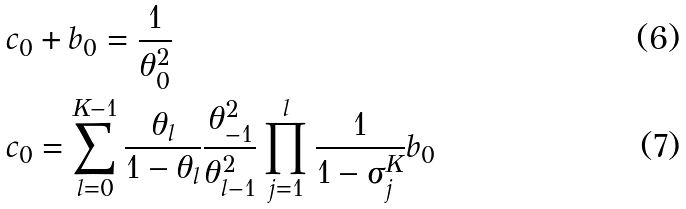<formula> <loc_0><loc_0><loc_500><loc_500>c _ { 0 } & + b _ { 0 } = \frac { 1 } { \theta _ { 0 } ^ { 2 } } \\ c _ { 0 } & = \sum _ { l = 0 } ^ { K - 1 } \frac { \theta _ { l } } { 1 - \theta _ { l } } \frac { \theta _ { - 1 } ^ { 2 } } { \theta _ { l - 1 } ^ { 2 } } \prod _ { j = 1 } ^ { l } \frac { 1 } { 1 - \sigma ^ { K } _ { j } } b _ { 0 }</formula> 